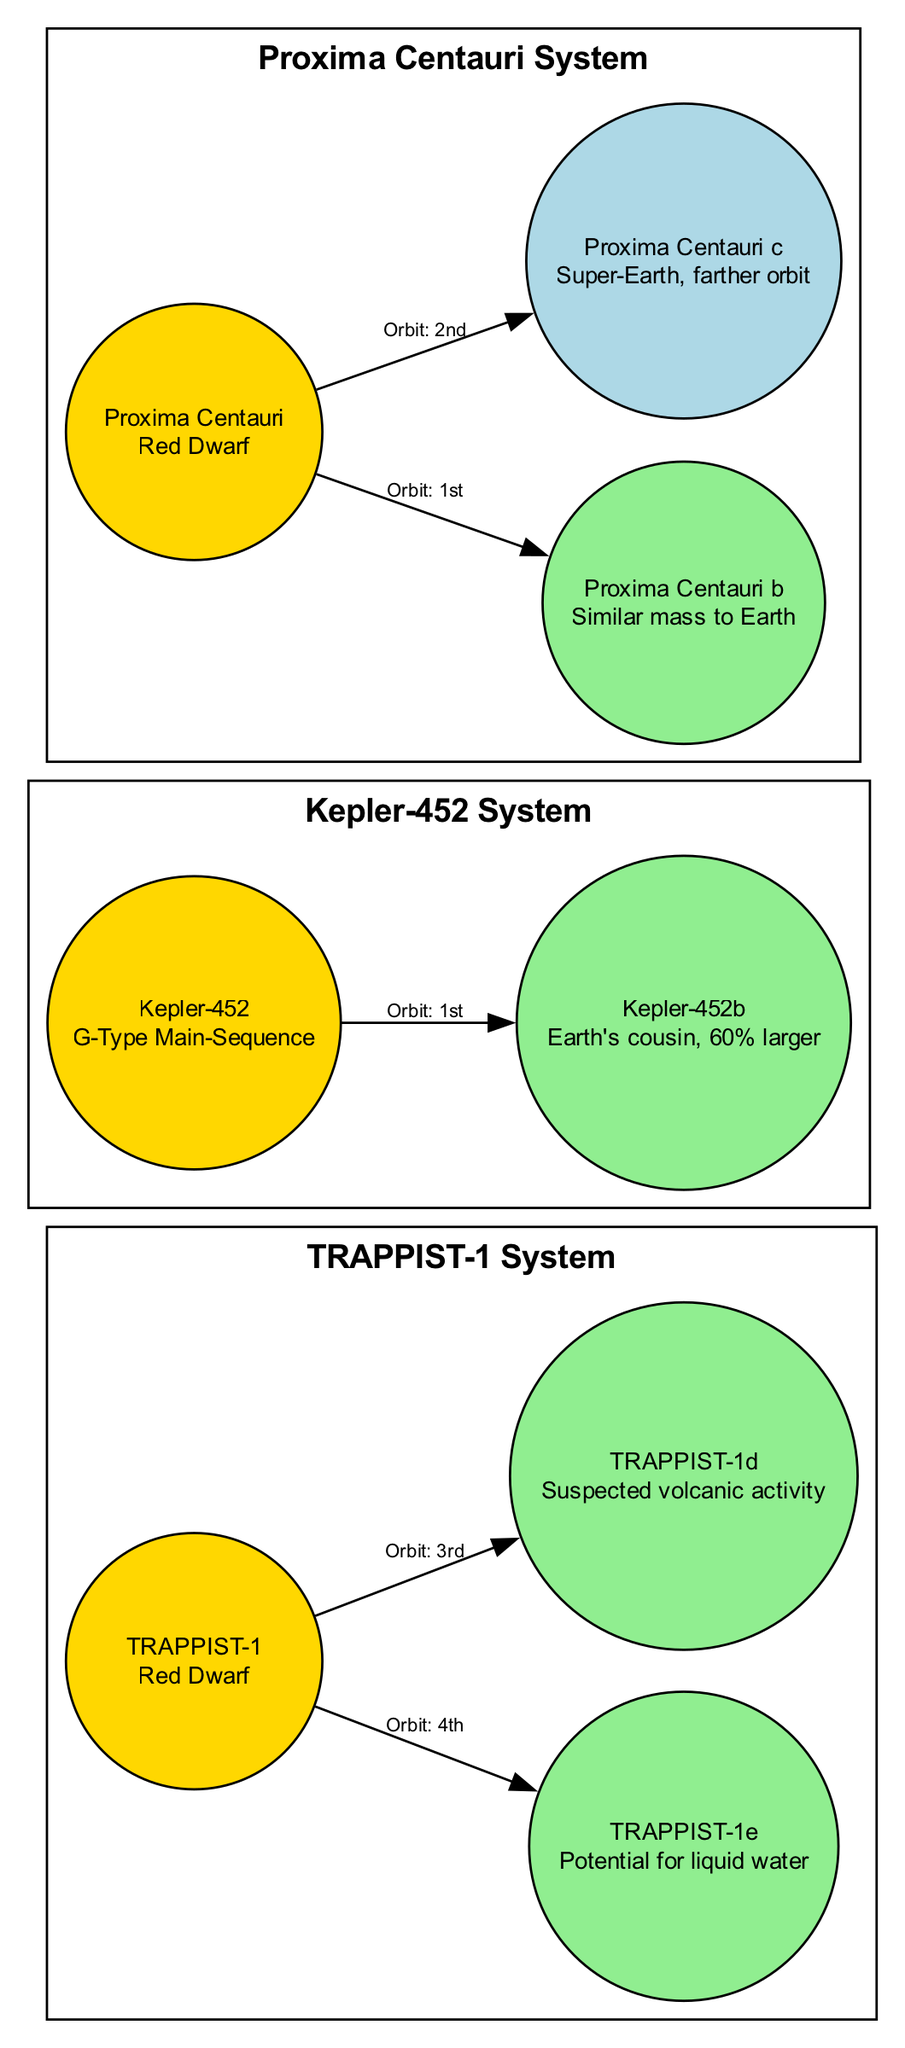What is the star type of TRAPPIST-1? The diagram specifies the star "TRAPPIST-1" as a "Red Dwarf". This information can be found in the properties of the star node within the diagram.
Answer: Red Dwarf How many planets are in the Kepler-452 system? The nodes connected to the "Kepler-452" star indicate there is 1 planet, which is "Kepler-452b". The edges connecting the nodes confirm this relationship.
Answer: 1 Which planet in the Proxima Centauri system is in the habitable zone? The properties of the planets within the "Proxima Centauri" system indicate that only "Proxima Centauri b" is within the habitable zone, as noted in its properties.
Answer: Proxima Centauri b What notable feature distinguishes TRAPPIST-1 from other stars? The diagram highlights that "TRAPPIST-1" has 7 Earth-sized planets as a notable feature, which sets it apart from the other stars depicted in the diagram.
Answer: 7 Earth-sized planets Which planet orbits the closest star to the Sun? The diagram indicates that "Proxima Centauri" is the closest star to the Sun and the planet that orbits it is "Proxima Centauri b". This connection is evident through the edge labeling in the diagram.
Answer: Proxima Centauri b What is the notable feature of Kepler-452? The diagram specifies that "Kepler-452" is notable for being similar to the Sun, which is mentioned in the star's properties.
Answer: Similar to the Sun Which planet is suspected to have volcanic activity? In the diagram, "TRAPPIST-1d" is noted for its suspected volcanic activity as a unique feature within its properties.
Answer: TRAPPIST-1d How many planets orbit around Proxima Centauri? The diagram shows that there are 2 planets orbiting "Proxima Centauri", specifically "Proxima Centauri b" and "Proxima Centauri c", which can be verified through the edges connecting the nodes.
Answer: 2 Which planet is referred to as Earth's cousin? The diagram highlights "Kepler-452b" as being "Earth's cousin" in its notable features, which implies its size and potential habitability.
Answer: Kepler-452b 